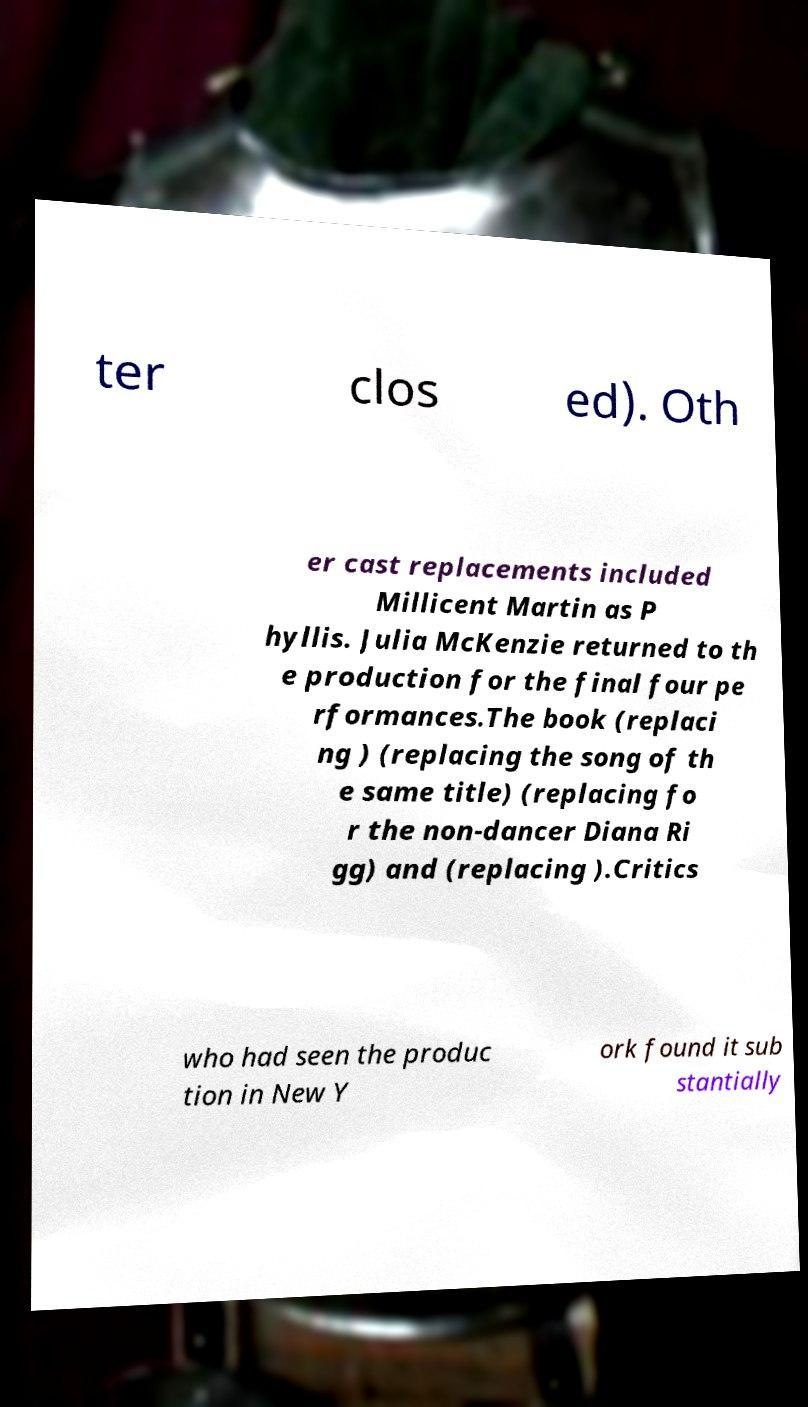What messages or text are displayed in this image? I need them in a readable, typed format. ter clos ed). Oth er cast replacements included Millicent Martin as P hyllis. Julia McKenzie returned to th e production for the final four pe rformances.The book (replaci ng ) (replacing the song of th e same title) (replacing fo r the non-dancer Diana Ri gg) and (replacing ).Critics who had seen the produc tion in New Y ork found it sub stantially 